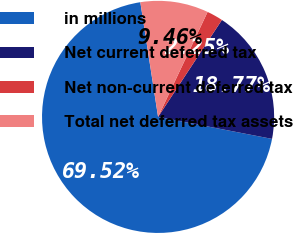Convert chart to OTSL. <chart><loc_0><loc_0><loc_500><loc_500><pie_chart><fcel>in millions<fcel>Net current deferred tax<fcel>Net non-current deferred tax<fcel>Total net deferred tax assets<nl><fcel>69.52%<fcel>18.77%<fcel>2.25%<fcel>9.46%<nl></chart> 